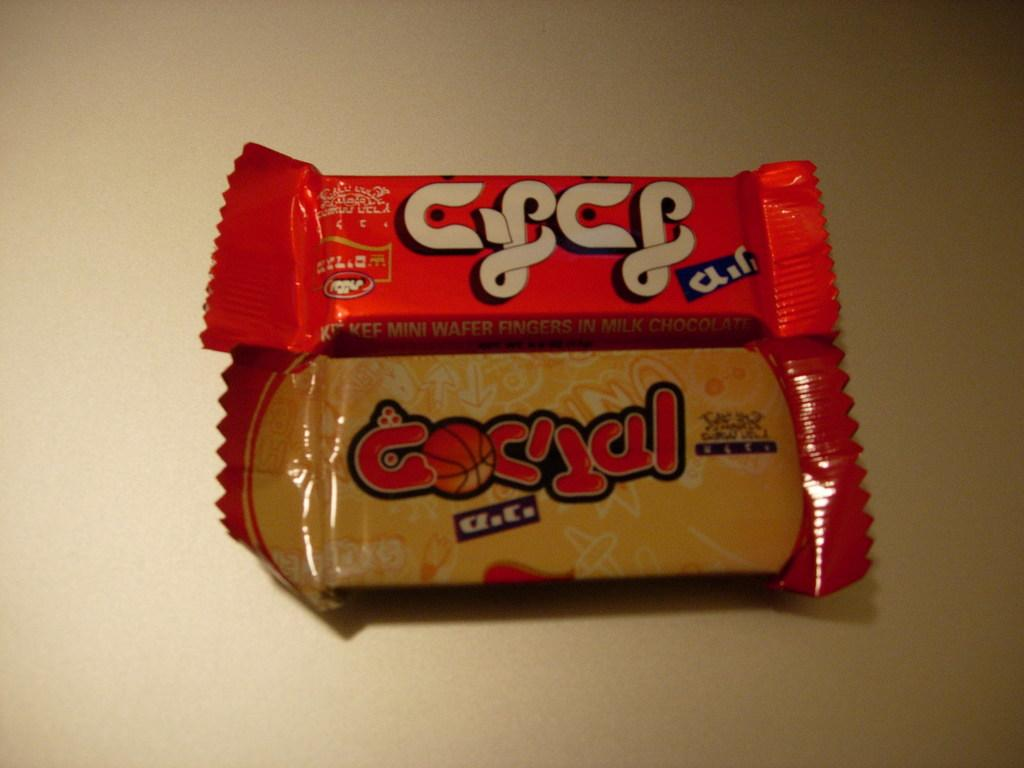What type of food can be seen in the image? There are chocolates in the image. Can you describe the background of the image? The background of the image is cream-colored. What type of development can be seen in the image? There is no development or construction project visible in the image; it features chocolates and a cream-colored background. How many attempts were made to create the honey in the image? There is no honey present in the image, and therefore no attempts can be counted. 